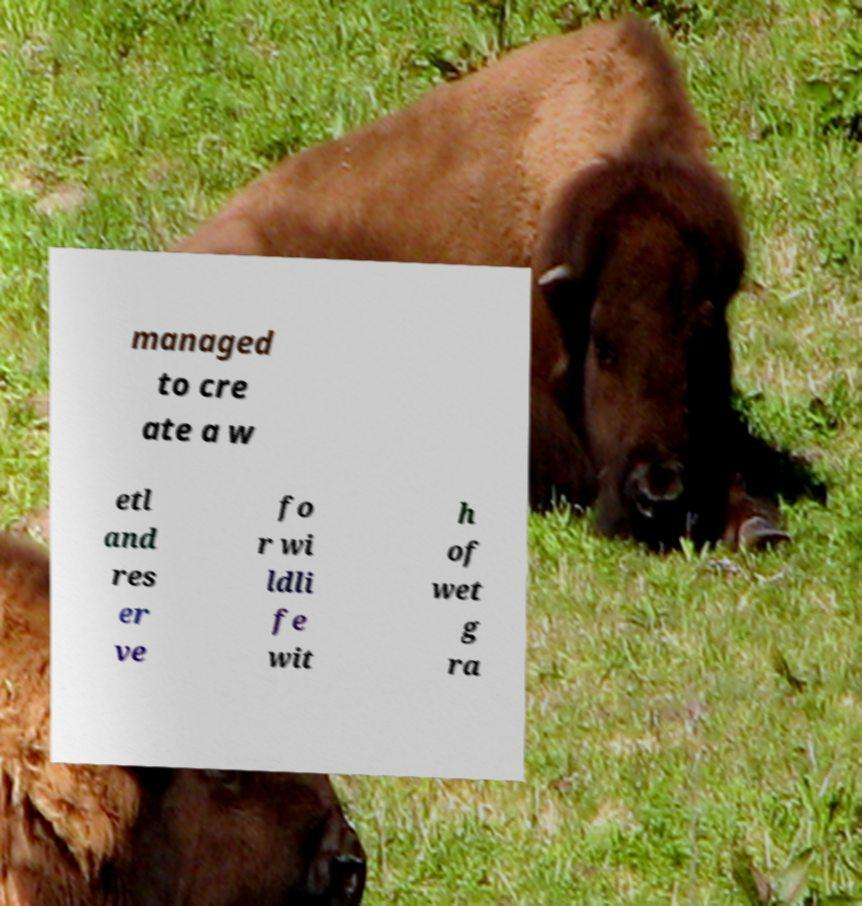Could you assist in decoding the text presented in this image and type it out clearly? managed to cre ate a w etl and res er ve fo r wi ldli fe wit h of wet g ra 